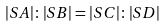Convert formula to latex. <formula><loc_0><loc_0><loc_500><loc_500>| S A | \colon | S B | = | S C | \colon | S D |</formula> 